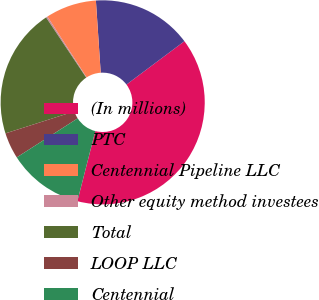<chart> <loc_0><loc_0><loc_500><loc_500><pie_chart><fcel>(In millions)<fcel>PTC<fcel>Centennial Pipeline LLC<fcel>Other equity method investees<fcel>Total<fcel>LOOP LLC<fcel>Centennial<nl><fcel>39.21%<fcel>15.84%<fcel>8.05%<fcel>0.25%<fcel>20.56%<fcel>4.15%<fcel>11.94%<nl></chart> 